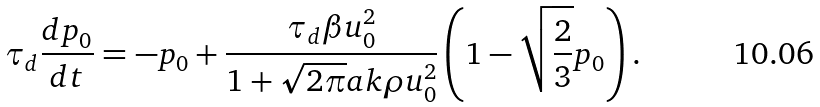<formula> <loc_0><loc_0><loc_500><loc_500>\tau _ { d } \frac { d p _ { 0 } } { d t } = - p _ { 0 } + \frac { \tau _ { d } \beta u _ { 0 } ^ { 2 } } { 1 + \sqrt { 2 \pi } a k \rho u _ { 0 } ^ { 2 } } \left ( 1 - \sqrt { \frac { 2 } { 3 } } p _ { 0 } \right ) .</formula> 